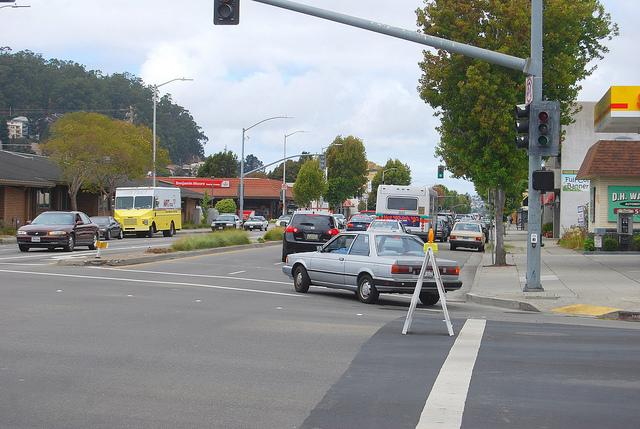What type of traffic does this road have?

Choices:
A) heavy
B) tractor
C) herded animal
D) light heavy 